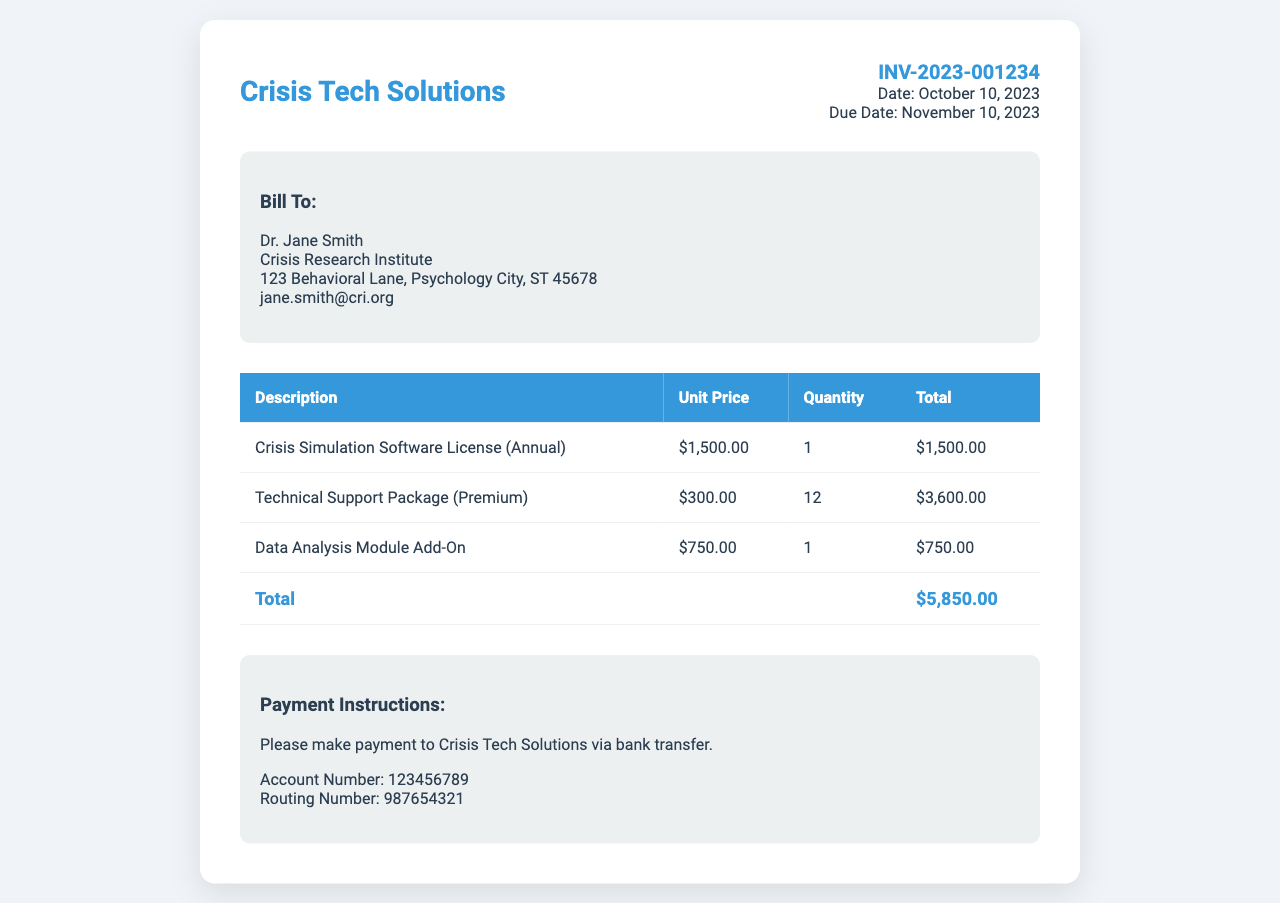What is the invoice number? The invoice number is stated at the top of the document under invoice details.
Answer: INV-2023-001234 Who is the bill recipient? The bill recipient's name is listed in the "Bill To" section.
Answer: Dr. Jane Smith What is the total amount due? The total amount is found in the total row of the invoice table.
Answer: $5,850.00 How much does the Crisis Simulation Software License cost? The cost for the Crisis Simulation Software License is specified in the invoice table.
Answer: $1,500.00 How many months of technical support are included in the package? The quantity of the technical support package reflects the number of months included.
Answer: 12 What is the due date for the invoice payment? The due date is mentioned in the invoice details section.
Answer: November 10, 2023 What type of payment method is requested? The payment instructions indicate the preferred method for payment.
Answer: Bank transfer What additional module is included with the software? The add-on module mentioned in the invoice describes an additional feature available for the software.
Answer: Data Analysis Module What is the total price of the Technical Support Package? The total for the Technical Support Package is calculated as unit price multiplied by quantity in the invoice table.
Answer: $3,600.00 